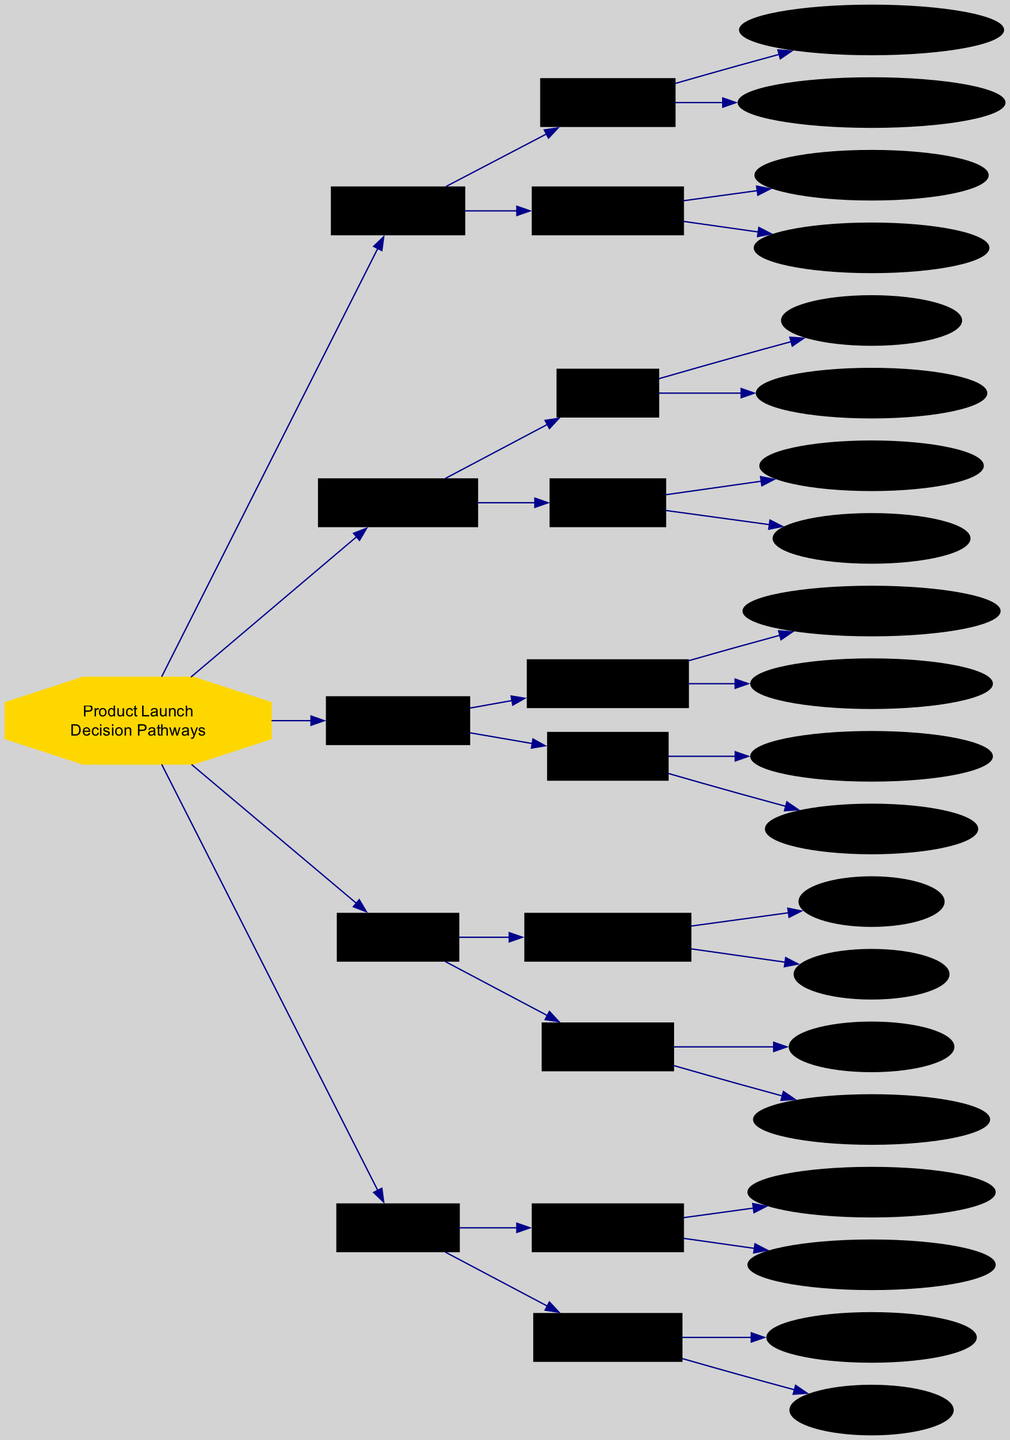What are the two main branches under Market Research? The diagram indicates that under Market Research, there are two main branches: Customer Trends and Competitor Analysis.
Answer: Customer Trends, Competitor Analysis How many promotional channels are identified in the Marketing Strategy? Looking at the Marketing Strategy node, there are two listed promotional channels: Social Media Campaigns and Influencer Partnerships. Hence, the count is 2.
Answer: 2 What indicates the initial sales projections in the Sales Forecast section? The Sales Forecast section specifically lists Initial Sales Projections as 1-3 Months and 6-12 Months, indicating two different time frames for sales projections.
Answer: 1-3 Months, 6-12 Months Which product development aspect focuses on pricing? Within the Product Development section, the Cost Analysis is directly related to pricing, highlighting the importance of evaluating manufacturing costs and retail price points in that aspect.
Answer: Cost Analysis What would be the feedback tools to assess customer response? In the Feedback Loop section, two tools are identified for customer response: Post-Purchase Surveys and Social Media Sentiment. These tools provide insight into customer feedback and perceptions.
Answer: Post-Purchase Surveys, Social Media Sentiment If a new product focuses on sustainable features, which node should be prioritized? Focusing on sustainable features suggests that Eco-friendly Materials should be prioritized under the Feature Set within the Product Development section. This indicates an alignment with sustainability preferences noted in Market Research.
Answer: Feature Set Which seasonal impact is highlighted under Sales Forecast? The Seasonal Impact section under Sales Forecast lists two key periods: Holiday Rush and Back-to-School Period, focusing on timing for product launches to align with high sales activity.
Answer: Holiday Rush, Back-to-School Period How does the Customer Feedback node contribute to sales strategy? The Customer Feedback node, part of the Feedback Loop, provides essential data through Post-Purchase Surveys and Social Media Sentiment, which can be analyzed to inform future sales strategies and product improvements.
Answer: Customer Feedback What is the connection between Virtual Launch Webinar and Promotional Channels? The Virtual Launch Webinar is categorized under Launch Events within the Marketing Strategy, indicating that it serves as a specific type of promotional channel used to engage customers during product launches.
Answer: Launch Events What is the first step recommended in the decision pathways? The first step in the decision pathways is Market Research, which serves as the groundwork for devising strategies before moving on to Product Development and Marketing Strategy.
Answer: Market Research 